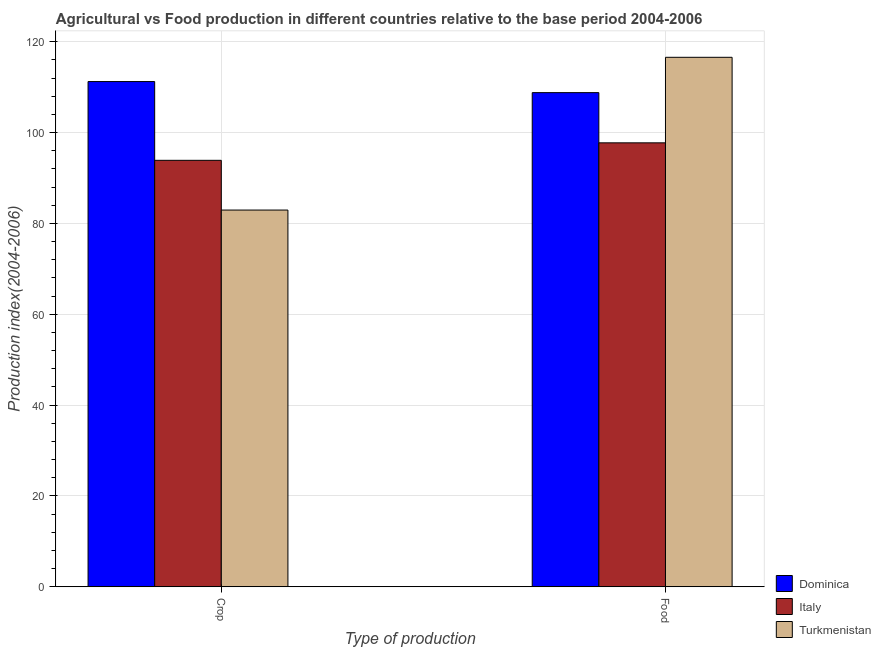How many different coloured bars are there?
Provide a short and direct response. 3. How many groups of bars are there?
Keep it short and to the point. 2. Are the number of bars per tick equal to the number of legend labels?
Offer a very short reply. Yes. Are the number of bars on each tick of the X-axis equal?
Ensure brevity in your answer.  Yes. How many bars are there on the 2nd tick from the left?
Make the answer very short. 3. What is the label of the 1st group of bars from the left?
Your response must be concise. Crop. What is the crop production index in Italy?
Make the answer very short. 93.88. Across all countries, what is the maximum food production index?
Your response must be concise. 116.56. Across all countries, what is the minimum crop production index?
Keep it short and to the point. 82.93. In which country was the crop production index maximum?
Offer a very short reply. Dominica. In which country was the food production index minimum?
Ensure brevity in your answer.  Italy. What is the total food production index in the graph?
Provide a short and direct response. 323.07. What is the difference between the food production index in Dominica and that in Turkmenistan?
Offer a terse response. -7.78. What is the difference between the food production index in Dominica and the crop production index in Turkmenistan?
Offer a terse response. 25.85. What is the average crop production index per country?
Your answer should be very brief. 96.01. What is the difference between the crop production index and food production index in Turkmenistan?
Make the answer very short. -33.63. In how many countries, is the food production index greater than 32 ?
Give a very brief answer. 3. What is the ratio of the food production index in Italy to that in Turkmenistan?
Ensure brevity in your answer.  0.84. In how many countries, is the crop production index greater than the average crop production index taken over all countries?
Your response must be concise. 1. What does the 3rd bar from the left in Food represents?
Provide a short and direct response. Turkmenistan. What does the 3rd bar from the right in Food represents?
Your answer should be very brief. Dominica. How many countries are there in the graph?
Ensure brevity in your answer.  3. How many legend labels are there?
Provide a short and direct response. 3. How are the legend labels stacked?
Your answer should be very brief. Vertical. What is the title of the graph?
Provide a short and direct response. Agricultural vs Food production in different countries relative to the base period 2004-2006. What is the label or title of the X-axis?
Your answer should be very brief. Type of production. What is the label or title of the Y-axis?
Keep it short and to the point. Production index(2004-2006). What is the Production index(2004-2006) in Dominica in Crop?
Provide a succinct answer. 111.22. What is the Production index(2004-2006) of Italy in Crop?
Your response must be concise. 93.88. What is the Production index(2004-2006) in Turkmenistan in Crop?
Your answer should be compact. 82.93. What is the Production index(2004-2006) of Dominica in Food?
Your answer should be very brief. 108.78. What is the Production index(2004-2006) of Italy in Food?
Keep it short and to the point. 97.73. What is the Production index(2004-2006) of Turkmenistan in Food?
Provide a short and direct response. 116.56. Across all Type of production, what is the maximum Production index(2004-2006) in Dominica?
Provide a short and direct response. 111.22. Across all Type of production, what is the maximum Production index(2004-2006) of Italy?
Make the answer very short. 97.73. Across all Type of production, what is the maximum Production index(2004-2006) in Turkmenistan?
Your response must be concise. 116.56. Across all Type of production, what is the minimum Production index(2004-2006) of Dominica?
Keep it short and to the point. 108.78. Across all Type of production, what is the minimum Production index(2004-2006) in Italy?
Ensure brevity in your answer.  93.88. Across all Type of production, what is the minimum Production index(2004-2006) in Turkmenistan?
Offer a terse response. 82.93. What is the total Production index(2004-2006) of Dominica in the graph?
Keep it short and to the point. 220. What is the total Production index(2004-2006) of Italy in the graph?
Your answer should be very brief. 191.61. What is the total Production index(2004-2006) of Turkmenistan in the graph?
Provide a short and direct response. 199.49. What is the difference between the Production index(2004-2006) in Dominica in Crop and that in Food?
Your answer should be compact. 2.44. What is the difference between the Production index(2004-2006) in Italy in Crop and that in Food?
Ensure brevity in your answer.  -3.85. What is the difference between the Production index(2004-2006) in Turkmenistan in Crop and that in Food?
Keep it short and to the point. -33.63. What is the difference between the Production index(2004-2006) of Dominica in Crop and the Production index(2004-2006) of Italy in Food?
Ensure brevity in your answer.  13.49. What is the difference between the Production index(2004-2006) in Dominica in Crop and the Production index(2004-2006) in Turkmenistan in Food?
Your answer should be compact. -5.34. What is the difference between the Production index(2004-2006) of Italy in Crop and the Production index(2004-2006) of Turkmenistan in Food?
Give a very brief answer. -22.68. What is the average Production index(2004-2006) in Dominica per Type of production?
Offer a terse response. 110. What is the average Production index(2004-2006) in Italy per Type of production?
Make the answer very short. 95.81. What is the average Production index(2004-2006) in Turkmenistan per Type of production?
Make the answer very short. 99.75. What is the difference between the Production index(2004-2006) in Dominica and Production index(2004-2006) in Italy in Crop?
Your answer should be compact. 17.34. What is the difference between the Production index(2004-2006) of Dominica and Production index(2004-2006) of Turkmenistan in Crop?
Make the answer very short. 28.29. What is the difference between the Production index(2004-2006) in Italy and Production index(2004-2006) in Turkmenistan in Crop?
Your answer should be very brief. 10.95. What is the difference between the Production index(2004-2006) of Dominica and Production index(2004-2006) of Italy in Food?
Your answer should be very brief. 11.05. What is the difference between the Production index(2004-2006) of Dominica and Production index(2004-2006) of Turkmenistan in Food?
Offer a terse response. -7.78. What is the difference between the Production index(2004-2006) of Italy and Production index(2004-2006) of Turkmenistan in Food?
Make the answer very short. -18.83. What is the ratio of the Production index(2004-2006) of Dominica in Crop to that in Food?
Your answer should be very brief. 1.02. What is the ratio of the Production index(2004-2006) of Italy in Crop to that in Food?
Make the answer very short. 0.96. What is the ratio of the Production index(2004-2006) of Turkmenistan in Crop to that in Food?
Your answer should be very brief. 0.71. What is the difference between the highest and the second highest Production index(2004-2006) in Dominica?
Offer a very short reply. 2.44. What is the difference between the highest and the second highest Production index(2004-2006) in Italy?
Offer a terse response. 3.85. What is the difference between the highest and the second highest Production index(2004-2006) in Turkmenistan?
Keep it short and to the point. 33.63. What is the difference between the highest and the lowest Production index(2004-2006) in Dominica?
Ensure brevity in your answer.  2.44. What is the difference between the highest and the lowest Production index(2004-2006) of Italy?
Ensure brevity in your answer.  3.85. What is the difference between the highest and the lowest Production index(2004-2006) in Turkmenistan?
Provide a succinct answer. 33.63. 